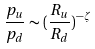Convert formula to latex. <formula><loc_0><loc_0><loc_500><loc_500>\frac { p _ { u } } { p _ { d } } \sim { ( \frac { R _ { u } } { R _ { d } } } ) ^ { - \zeta }</formula> 